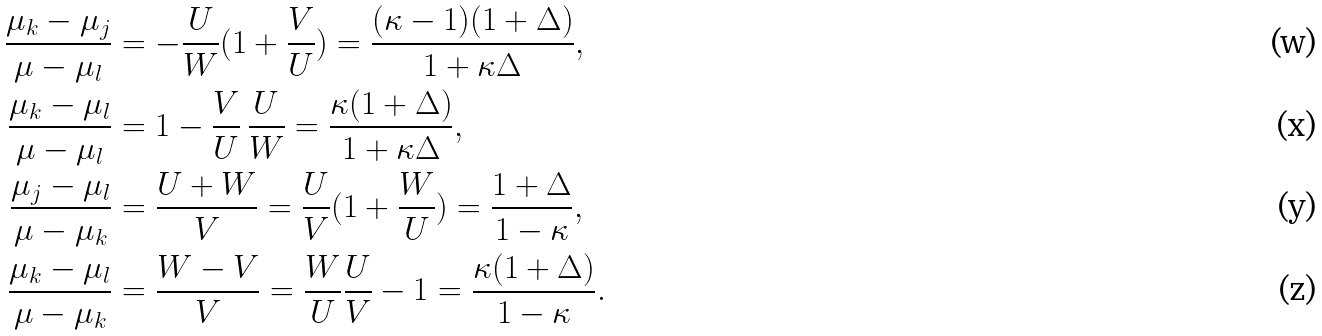Convert formula to latex. <formula><loc_0><loc_0><loc_500><loc_500>\frac { \mu _ { k } - \mu _ { j } } { \mu - \mu _ { l } } & = - \frac { U } { W } ( 1 + \frac { V } { U } ) = \frac { ( \kappa - 1 ) ( 1 + \Delta ) } { 1 + \kappa \Delta } , \\ \frac { \mu _ { k } - \mu _ { l } } { \mu - \mu _ { l } } & = 1 - \frac { V } { U } \, \frac { U } { W } = \frac { \kappa ( 1 + \Delta ) } { 1 + \kappa \Delta } , \\ \frac { \mu _ { j } - \mu _ { l } } { \mu - \mu _ { k } } & = \frac { U + W } V = \frac { U } { V } ( 1 + \frac { W } { U } ) = \frac { 1 + \Delta } { 1 - \kappa } , \\ \frac { \mu _ { k } - \mu _ { l } } { \mu - \mu _ { k } } & = \frac { W - V } { V } = \frac { W } { U } \frac { U } { V } - 1 = \frac { \kappa ( 1 + \Delta ) } { 1 - \kappa } .</formula> 